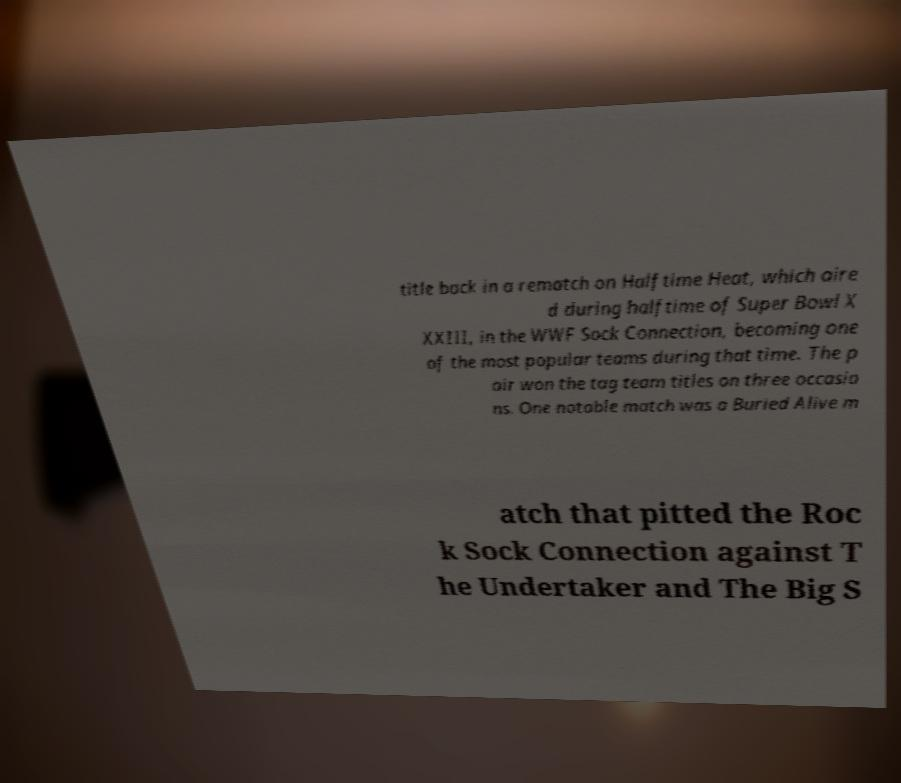Please identify and transcribe the text found in this image. title back in a rematch on Halftime Heat, which aire d during halftime of Super Bowl X XXIII, in the WWF Sock Connection, becoming one of the most popular teams during that time. The p air won the tag team titles on three occasio ns. One notable match was a Buried Alive m atch that pitted the Roc k Sock Connection against T he Undertaker and The Big S 